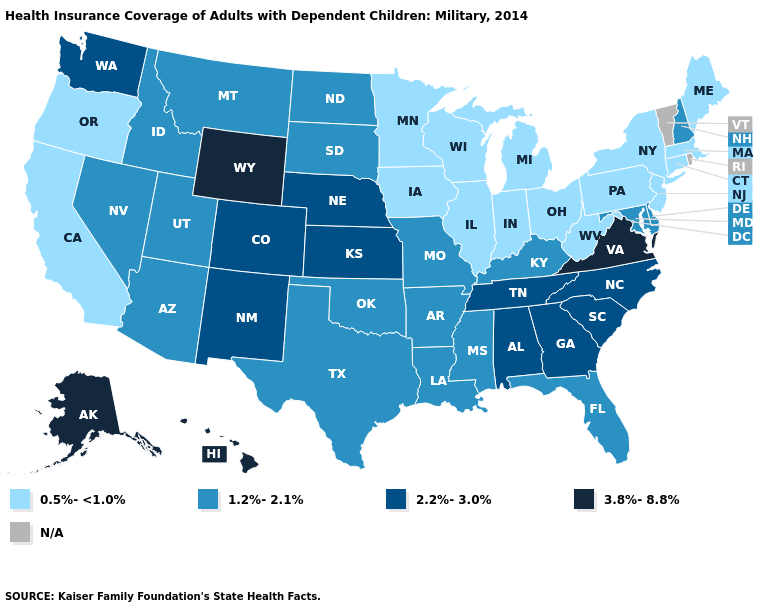Among the states that border Florida , which have the lowest value?
Give a very brief answer. Alabama, Georgia. What is the value of New Hampshire?
Quick response, please. 1.2%-2.1%. Which states have the lowest value in the USA?
Concise answer only. California, Connecticut, Illinois, Indiana, Iowa, Maine, Massachusetts, Michigan, Minnesota, New Jersey, New York, Ohio, Oregon, Pennsylvania, West Virginia, Wisconsin. What is the highest value in the USA?
Give a very brief answer. 3.8%-8.8%. What is the value of Maine?
Concise answer only. 0.5%-<1.0%. Does Washington have the lowest value in the USA?
Keep it brief. No. What is the value of Illinois?
Concise answer only. 0.5%-<1.0%. Does Wyoming have the highest value in the West?
Write a very short answer. Yes. What is the highest value in the West ?
Quick response, please. 3.8%-8.8%. What is the value of Delaware?
Quick response, please. 1.2%-2.1%. Name the states that have a value in the range 3.8%-8.8%?
Write a very short answer. Alaska, Hawaii, Virginia, Wyoming. Name the states that have a value in the range 2.2%-3.0%?
Keep it brief. Alabama, Colorado, Georgia, Kansas, Nebraska, New Mexico, North Carolina, South Carolina, Tennessee, Washington. Name the states that have a value in the range 3.8%-8.8%?
Quick response, please. Alaska, Hawaii, Virginia, Wyoming. What is the value of New Hampshire?
Answer briefly. 1.2%-2.1%. What is the value of Delaware?
Keep it brief. 1.2%-2.1%. 